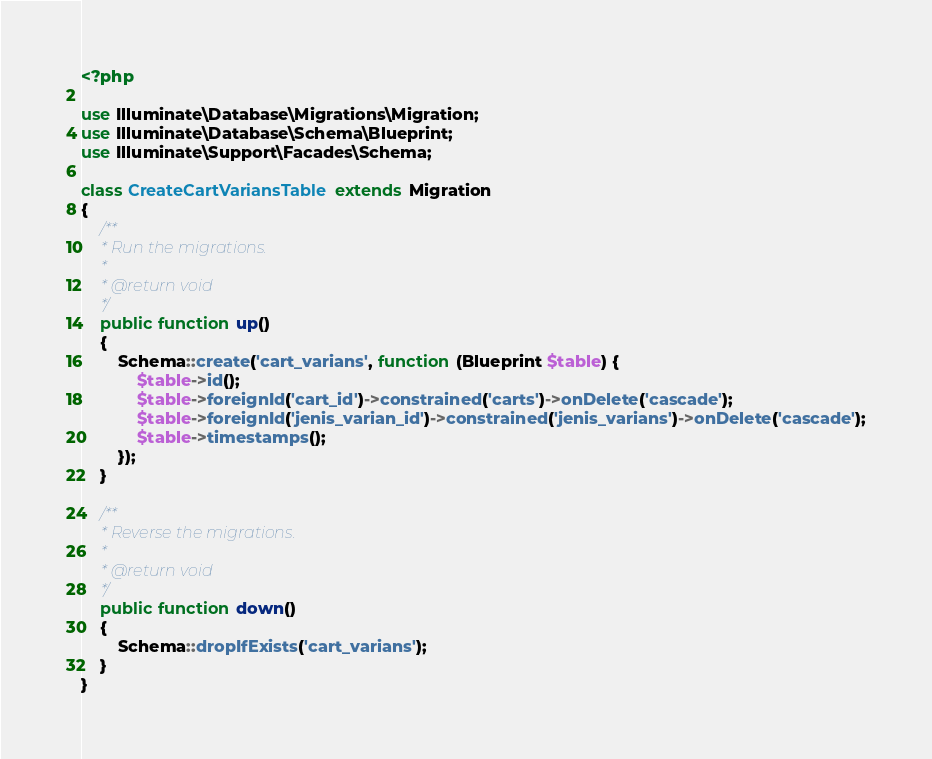<code> <loc_0><loc_0><loc_500><loc_500><_PHP_><?php

use Illuminate\Database\Migrations\Migration;
use Illuminate\Database\Schema\Blueprint;
use Illuminate\Support\Facades\Schema;

class CreateCartVariansTable extends Migration
{
    /**
     * Run the migrations.
     *
     * @return void
     */
    public function up()
    {
        Schema::create('cart_varians', function (Blueprint $table) {
            $table->id();
            $table->foreignId('cart_id')->constrained('carts')->onDelete('cascade');
            $table->foreignId('jenis_varian_id')->constrained('jenis_varians')->onDelete('cascade');
            $table->timestamps();
        });
    }

    /**
     * Reverse the migrations.
     *
     * @return void
     */
    public function down()
    {
        Schema::dropIfExists('cart_varians');
    }
}
</code> 